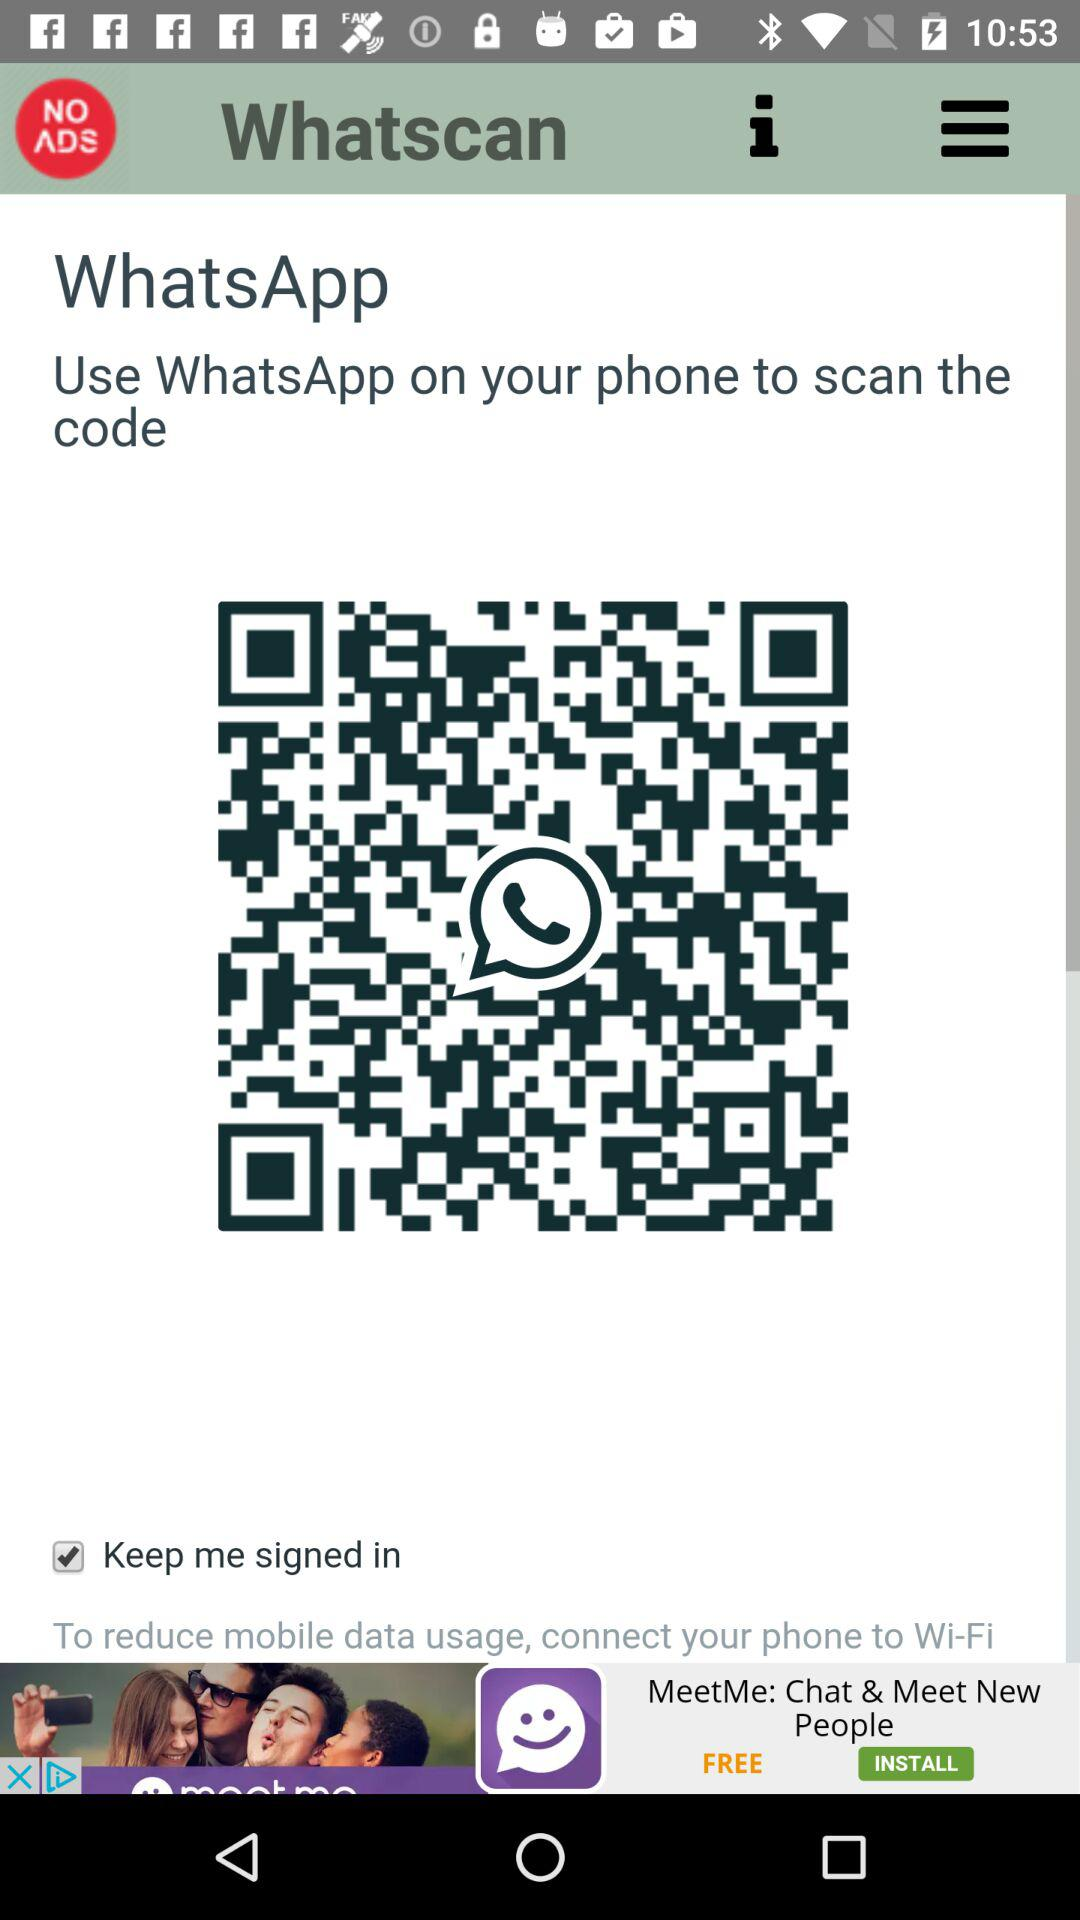What's the status of "Keep me signed in"? The status of "Keep me signed in" is "on". 